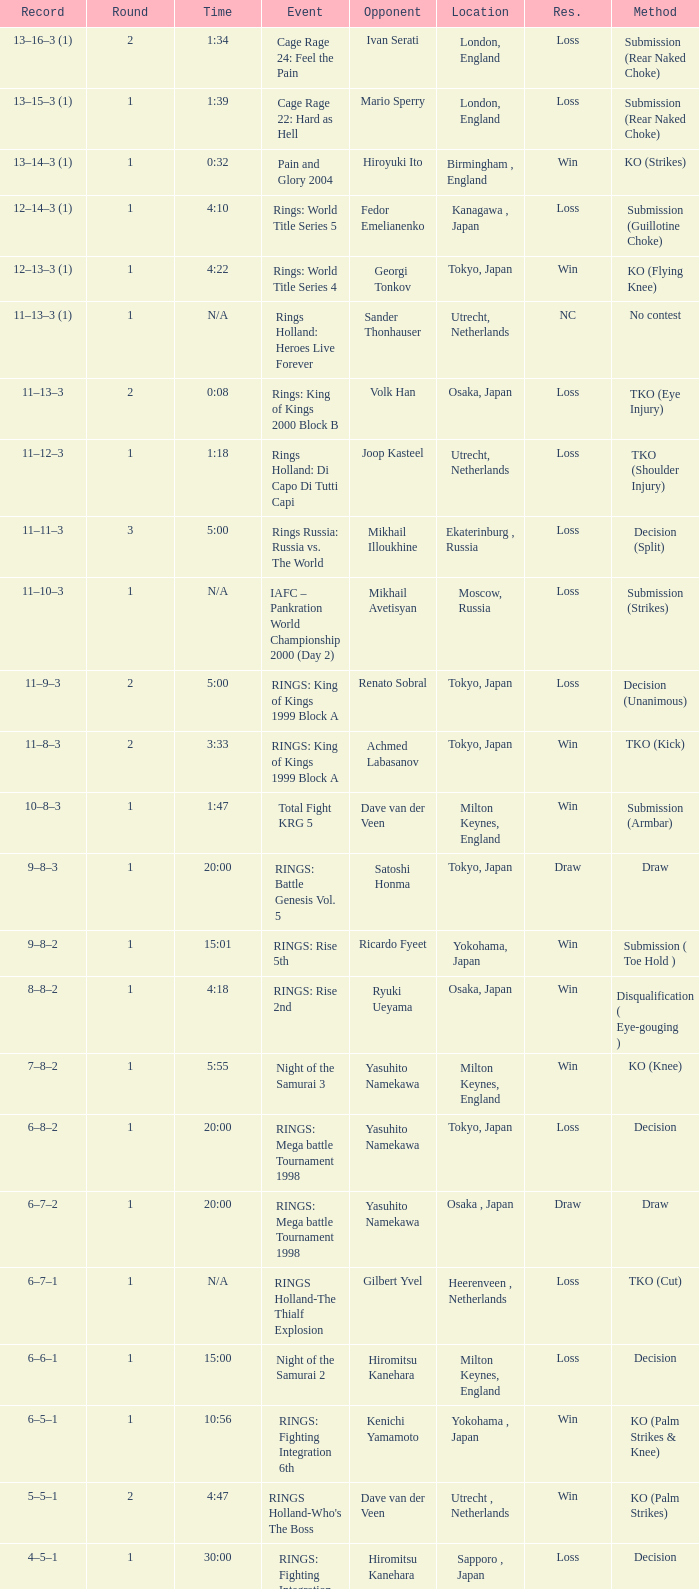Which event had an opponent of Yasuhito Namekawa with a decision method? RINGS: Mega battle Tournament 1998. 